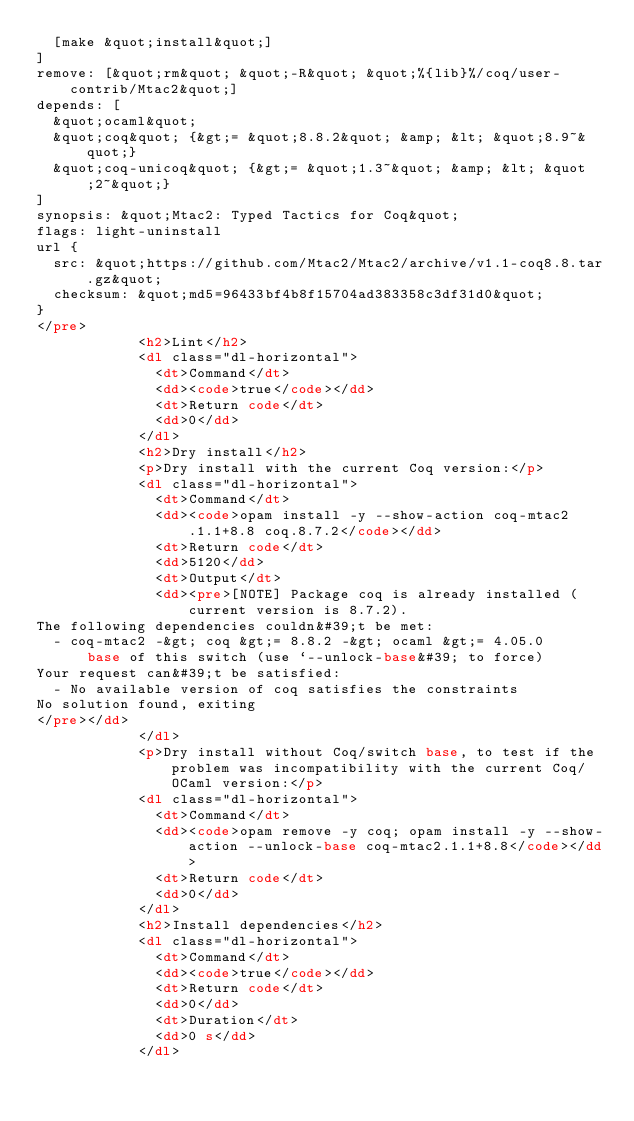Convert code to text. <code><loc_0><loc_0><loc_500><loc_500><_HTML_>  [make &quot;install&quot;]
]
remove: [&quot;rm&quot; &quot;-R&quot; &quot;%{lib}%/coq/user-contrib/Mtac2&quot;]
depends: [
  &quot;ocaml&quot;
  &quot;coq&quot; {&gt;= &quot;8.8.2&quot; &amp; &lt; &quot;8.9~&quot;}
  &quot;coq-unicoq&quot; {&gt;= &quot;1.3~&quot; &amp; &lt; &quot;2~&quot;}
]
synopsis: &quot;Mtac2: Typed Tactics for Coq&quot;
flags: light-uninstall
url {
  src: &quot;https://github.com/Mtac2/Mtac2/archive/v1.1-coq8.8.tar.gz&quot;
  checksum: &quot;md5=96433bf4b8f15704ad383358c3df31d0&quot;
}
</pre>
            <h2>Lint</h2>
            <dl class="dl-horizontal">
              <dt>Command</dt>
              <dd><code>true</code></dd>
              <dt>Return code</dt>
              <dd>0</dd>
            </dl>
            <h2>Dry install</h2>
            <p>Dry install with the current Coq version:</p>
            <dl class="dl-horizontal">
              <dt>Command</dt>
              <dd><code>opam install -y --show-action coq-mtac2.1.1+8.8 coq.8.7.2</code></dd>
              <dt>Return code</dt>
              <dd>5120</dd>
              <dt>Output</dt>
              <dd><pre>[NOTE] Package coq is already installed (current version is 8.7.2).
The following dependencies couldn&#39;t be met:
  - coq-mtac2 -&gt; coq &gt;= 8.8.2 -&gt; ocaml &gt;= 4.05.0
      base of this switch (use `--unlock-base&#39; to force)
Your request can&#39;t be satisfied:
  - No available version of coq satisfies the constraints
No solution found, exiting
</pre></dd>
            </dl>
            <p>Dry install without Coq/switch base, to test if the problem was incompatibility with the current Coq/OCaml version:</p>
            <dl class="dl-horizontal">
              <dt>Command</dt>
              <dd><code>opam remove -y coq; opam install -y --show-action --unlock-base coq-mtac2.1.1+8.8</code></dd>
              <dt>Return code</dt>
              <dd>0</dd>
            </dl>
            <h2>Install dependencies</h2>
            <dl class="dl-horizontal">
              <dt>Command</dt>
              <dd><code>true</code></dd>
              <dt>Return code</dt>
              <dd>0</dd>
              <dt>Duration</dt>
              <dd>0 s</dd>
            </dl></code> 